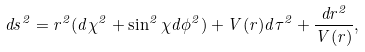Convert formula to latex. <formula><loc_0><loc_0><loc_500><loc_500>d s ^ { 2 } = r ^ { 2 } ( d \chi ^ { 2 } + \sin ^ { 2 } \chi d \phi ^ { 2 } ) + V ( r ) d \tau ^ { 2 } + \frac { d r ^ { 2 } } { V ( r ) } ,</formula> 